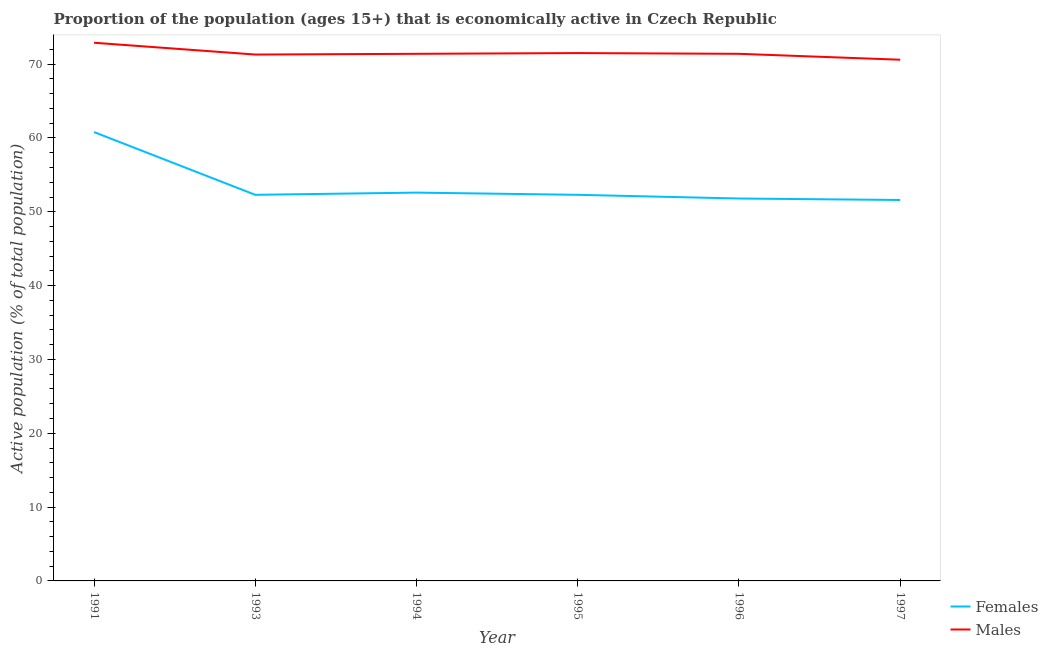How many different coloured lines are there?
Ensure brevity in your answer.  2. Does the line corresponding to percentage of economically active female population intersect with the line corresponding to percentage of economically active male population?
Keep it short and to the point. No. Is the number of lines equal to the number of legend labels?
Offer a terse response. Yes. What is the percentage of economically active male population in 1994?
Your answer should be compact. 71.4. Across all years, what is the maximum percentage of economically active female population?
Your response must be concise. 60.8. Across all years, what is the minimum percentage of economically active female population?
Make the answer very short. 51.6. In which year was the percentage of economically active male population maximum?
Offer a very short reply. 1991. In which year was the percentage of economically active male population minimum?
Your response must be concise. 1997. What is the total percentage of economically active male population in the graph?
Give a very brief answer. 429.1. What is the difference between the percentage of economically active female population in 1991 and that in 1993?
Give a very brief answer. 8.5. What is the difference between the percentage of economically active female population in 1991 and the percentage of economically active male population in 1993?
Offer a terse response. -10.5. What is the average percentage of economically active female population per year?
Give a very brief answer. 53.57. In the year 1995, what is the difference between the percentage of economically active male population and percentage of economically active female population?
Offer a terse response. 19.2. In how many years, is the percentage of economically active female population greater than 54 %?
Make the answer very short. 1. What is the ratio of the percentage of economically active female population in 1993 to that in 1997?
Provide a short and direct response. 1.01. Is the difference between the percentage of economically active female population in 1995 and 1997 greater than the difference between the percentage of economically active male population in 1995 and 1997?
Your response must be concise. No. What is the difference between the highest and the second highest percentage of economically active male population?
Offer a terse response. 1.4. What is the difference between the highest and the lowest percentage of economically active female population?
Provide a succinct answer. 9.2. In how many years, is the percentage of economically active male population greater than the average percentage of economically active male population taken over all years?
Ensure brevity in your answer.  1. Is the sum of the percentage of economically active male population in 1991 and 1993 greater than the maximum percentage of economically active female population across all years?
Your answer should be very brief. Yes. Does the percentage of economically active male population monotonically increase over the years?
Offer a very short reply. No. How many lines are there?
Keep it short and to the point. 2. Does the graph contain any zero values?
Offer a very short reply. No. Does the graph contain grids?
Make the answer very short. No. What is the title of the graph?
Ensure brevity in your answer.  Proportion of the population (ages 15+) that is economically active in Czech Republic. What is the label or title of the Y-axis?
Offer a terse response. Active population (% of total population). What is the Active population (% of total population) of Females in 1991?
Your answer should be compact. 60.8. What is the Active population (% of total population) in Males in 1991?
Ensure brevity in your answer.  72.9. What is the Active population (% of total population) of Females in 1993?
Offer a very short reply. 52.3. What is the Active population (% of total population) of Males in 1993?
Your answer should be very brief. 71.3. What is the Active population (% of total population) of Females in 1994?
Provide a short and direct response. 52.6. What is the Active population (% of total population) of Males in 1994?
Ensure brevity in your answer.  71.4. What is the Active population (% of total population) of Females in 1995?
Your answer should be very brief. 52.3. What is the Active population (% of total population) in Males in 1995?
Offer a very short reply. 71.5. What is the Active population (% of total population) in Females in 1996?
Keep it short and to the point. 51.8. What is the Active population (% of total population) of Males in 1996?
Offer a terse response. 71.4. What is the Active population (% of total population) in Females in 1997?
Provide a succinct answer. 51.6. What is the Active population (% of total population) in Males in 1997?
Make the answer very short. 70.6. Across all years, what is the maximum Active population (% of total population) of Females?
Keep it short and to the point. 60.8. Across all years, what is the maximum Active population (% of total population) of Males?
Make the answer very short. 72.9. Across all years, what is the minimum Active population (% of total population) in Females?
Provide a succinct answer. 51.6. Across all years, what is the minimum Active population (% of total population) of Males?
Keep it short and to the point. 70.6. What is the total Active population (% of total population) in Females in the graph?
Provide a succinct answer. 321.4. What is the total Active population (% of total population) of Males in the graph?
Your answer should be compact. 429.1. What is the difference between the Active population (% of total population) in Males in 1991 and that in 1993?
Keep it short and to the point. 1.6. What is the difference between the Active population (% of total population) in Females in 1991 and that in 1995?
Provide a succinct answer. 8.5. What is the difference between the Active population (% of total population) of Males in 1991 and that in 1995?
Keep it short and to the point. 1.4. What is the difference between the Active population (% of total population) of Males in 1991 and that in 1996?
Your response must be concise. 1.5. What is the difference between the Active population (% of total population) in Females in 1991 and that in 1997?
Your answer should be very brief. 9.2. What is the difference between the Active population (% of total population) in Females in 1993 and that in 1995?
Your response must be concise. 0. What is the difference between the Active population (% of total population) of Males in 1993 and that in 1995?
Your answer should be very brief. -0.2. What is the difference between the Active population (% of total population) in Males in 1993 and that in 1997?
Provide a short and direct response. 0.7. What is the difference between the Active population (% of total population) in Females in 1994 and that in 1995?
Give a very brief answer. 0.3. What is the difference between the Active population (% of total population) in Females in 1994 and that in 1996?
Your answer should be very brief. 0.8. What is the difference between the Active population (% of total population) of Males in 1994 and that in 1996?
Make the answer very short. 0. What is the difference between the Active population (% of total population) of Males in 1994 and that in 1997?
Your answer should be compact. 0.8. What is the difference between the Active population (% of total population) in Males in 1995 and that in 1997?
Offer a terse response. 0.9. What is the difference between the Active population (% of total population) in Females in 1996 and that in 1997?
Keep it short and to the point. 0.2. What is the difference between the Active population (% of total population) in Females in 1991 and the Active population (% of total population) in Males in 1997?
Give a very brief answer. -9.8. What is the difference between the Active population (% of total population) of Females in 1993 and the Active population (% of total population) of Males in 1994?
Offer a very short reply. -19.1. What is the difference between the Active population (% of total population) of Females in 1993 and the Active population (% of total population) of Males in 1995?
Offer a terse response. -19.2. What is the difference between the Active population (% of total population) in Females in 1993 and the Active population (% of total population) in Males in 1996?
Offer a terse response. -19.1. What is the difference between the Active population (% of total population) of Females in 1993 and the Active population (% of total population) of Males in 1997?
Offer a very short reply. -18.3. What is the difference between the Active population (% of total population) in Females in 1994 and the Active population (% of total population) in Males in 1995?
Ensure brevity in your answer.  -18.9. What is the difference between the Active population (% of total population) in Females in 1994 and the Active population (% of total population) in Males in 1996?
Offer a terse response. -18.8. What is the difference between the Active population (% of total population) of Females in 1994 and the Active population (% of total population) of Males in 1997?
Keep it short and to the point. -18. What is the difference between the Active population (% of total population) in Females in 1995 and the Active population (% of total population) in Males in 1996?
Keep it short and to the point. -19.1. What is the difference between the Active population (% of total population) in Females in 1995 and the Active population (% of total population) in Males in 1997?
Offer a terse response. -18.3. What is the difference between the Active population (% of total population) of Females in 1996 and the Active population (% of total population) of Males in 1997?
Offer a very short reply. -18.8. What is the average Active population (% of total population) in Females per year?
Your answer should be compact. 53.57. What is the average Active population (% of total population) in Males per year?
Ensure brevity in your answer.  71.52. In the year 1994, what is the difference between the Active population (% of total population) in Females and Active population (% of total population) in Males?
Make the answer very short. -18.8. In the year 1995, what is the difference between the Active population (% of total population) of Females and Active population (% of total population) of Males?
Your response must be concise. -19.2. In the year 1996, what is the difference between the Active population (% of total population) in Females and Active population (% of total population) in Males?
Offer a terse response. -19.6. In the year 1997, what is the difference between the Active population (% of total population) in Females and Active population (% of total population) in Males?
Provide a short and direct response. -19. What is the ratio of the Active population (% of total population) of Females in 1991 to that in 1993?
Provide a succinct answer. 1.16. What is the ratio of the Active population (% of total population) of Males in 1991 to that in 1993?
Provide a succinct answer. 1.02. What is the ratio of the Active population (% of total population) of Females in 1991 to that in 1994?
Your answer should be compact. 1.16. What is the ratio of the Active population (% of total population) in Females in 1991 to that in 1995?
Offer a terse response. 1.16. What is the ratio of the Active population (% of total population) in Males in 1991 to that in 1995?
Offer a terse response. 1.02. What is the ratio of the Active population (% of total population) in Females in 1991 to that in 1996?
Provide a short and direct response. 1.17. What is the ratio of the Active population (% of total population) of Females in 1991 to that in 1997?
Offer a terse response. 1.18. What is the ratio of the Active population (% of total population) of Males in 1991 to that in 1997?
Make the answer very short. 1.03. What is the ratio of the Active population (% of total population) of Females in 1993 to that in 1995?
Ensure brevity in your answer.  1. What is the ratio of the Active population (% of total population) in Females in 1993 to that in 1996?
Provide a short and direct response. 1.01. What is the ratio of the Active population (% of total population) in Females in 1993 to that in 1997?
Your answer should be very brief. 1.01. What is the ratio of the Active population (% of total population) in Males in 1993 to that in 1997?
Your answer should be compact. 1.01. What is the ratio of the Active population (% of total population) of Males in 1994 to that in 1995?
Give a very brief answer. 1. What is the ratio of the Active population (% of total population) of Females in 1994 to that in 1996?
Make the answer very short. 1.02. What is the ratio of the Active population (% of total population) in Males in 1994 to that in 1996?
Make the answer very short. 1. What is the ratio of the Active population (% of total population) of Females in 1994 to that in 1997?
Provide a succinct answer. 1.02. What is the ratio of the Active population (% of total population) in Males in 1994 to that in 1997?
Provide a succinct answer. 1.01. What is the ratio of the Active population (% of total population) in Females in 1995 to that in 1996?
Provide a succinct answer. 1.01. What is the ratio of the Active population (% of total population) of Females in 1995 to that in 1997?
Offer a terse response. 1.01. What is the ratio of the Active population (% of total population) of Males in 1995 to that in 1997?
Keep it short and to the point. 1.01. What is the ratio of the Active population (% of total population) in Females in 1996 to that in 1997?
Offer a very short reply. 1. What is the ratio of the Active population (% of total population) in Males in 1996 to that in 1997?
Ensure brevity in your answer.  1.01. What is the difference between the highest and the second highest Active population (% of total population) of Females?
Offer a terse response. 8.2. What is the difference between the highest and the second highest Active population (% of total population) of Males?
Your answer should be very brief. 1.4. What is the difference between the highest and the lowest Active population (% of total population) of Females?
Your answer should be compact. 9.2. What is the difference between the highest and the lowest Active population (% of total population) of Males?
Give a very brief answer. 2.3. 